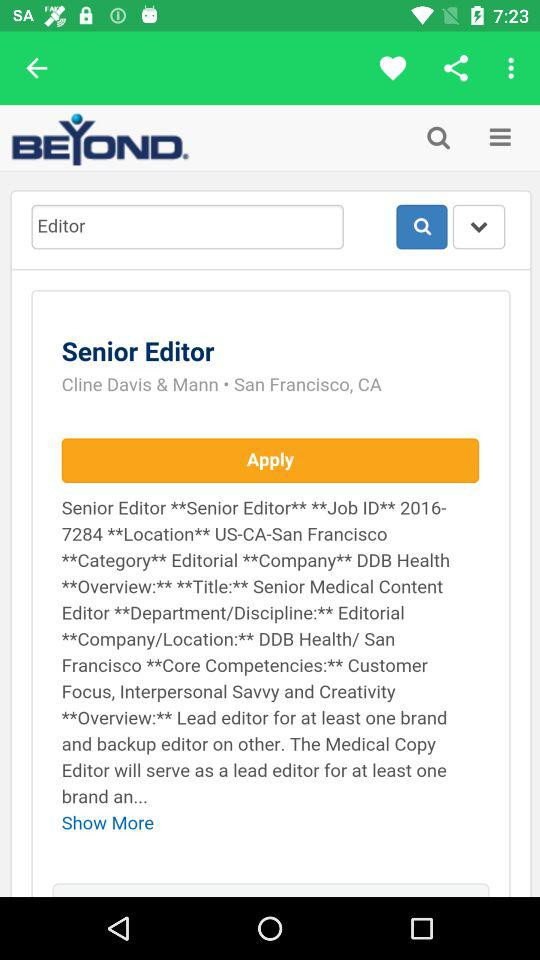What is the mentioned location? The mentioned location is San Francisco, CA. 